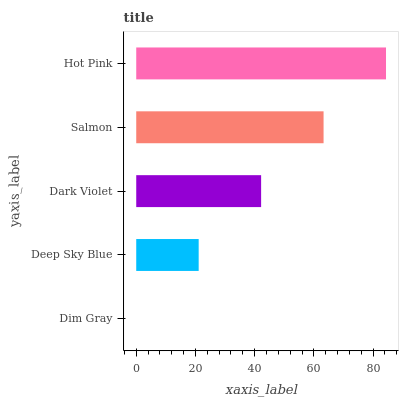Is Dim Gray the minimum?
Answer yes or no. Yes. Is Hot Pink the maximum?
Answer yes or no. Yes. Is Deep Sky Blue the minimum?
Answer yes or no. No. Is Deep Sky Blue the maximum?
Answer yes or no. No. Is Deep Sky Blue greater than Dim Gray?
Answer yes or no. Yes. Is Dim Gray less than Deep Sky Blue?
Answer yes or no. Yes. Is Dim Gray greater than Deep Sky Blue?
Answer yes or no. No. Is Deep Sky Blue less than Dim Gray?
Answer yes or no. No. Is Dark Violet the high median?
Answer yes or no. Yes. Is Dark Violet the low median?
Answer yes or no. Yes. Is Dim Gray the high median?
Answer yes or no. No. Is Deep Sky Blue the low median?
Answer yes or no. No. 